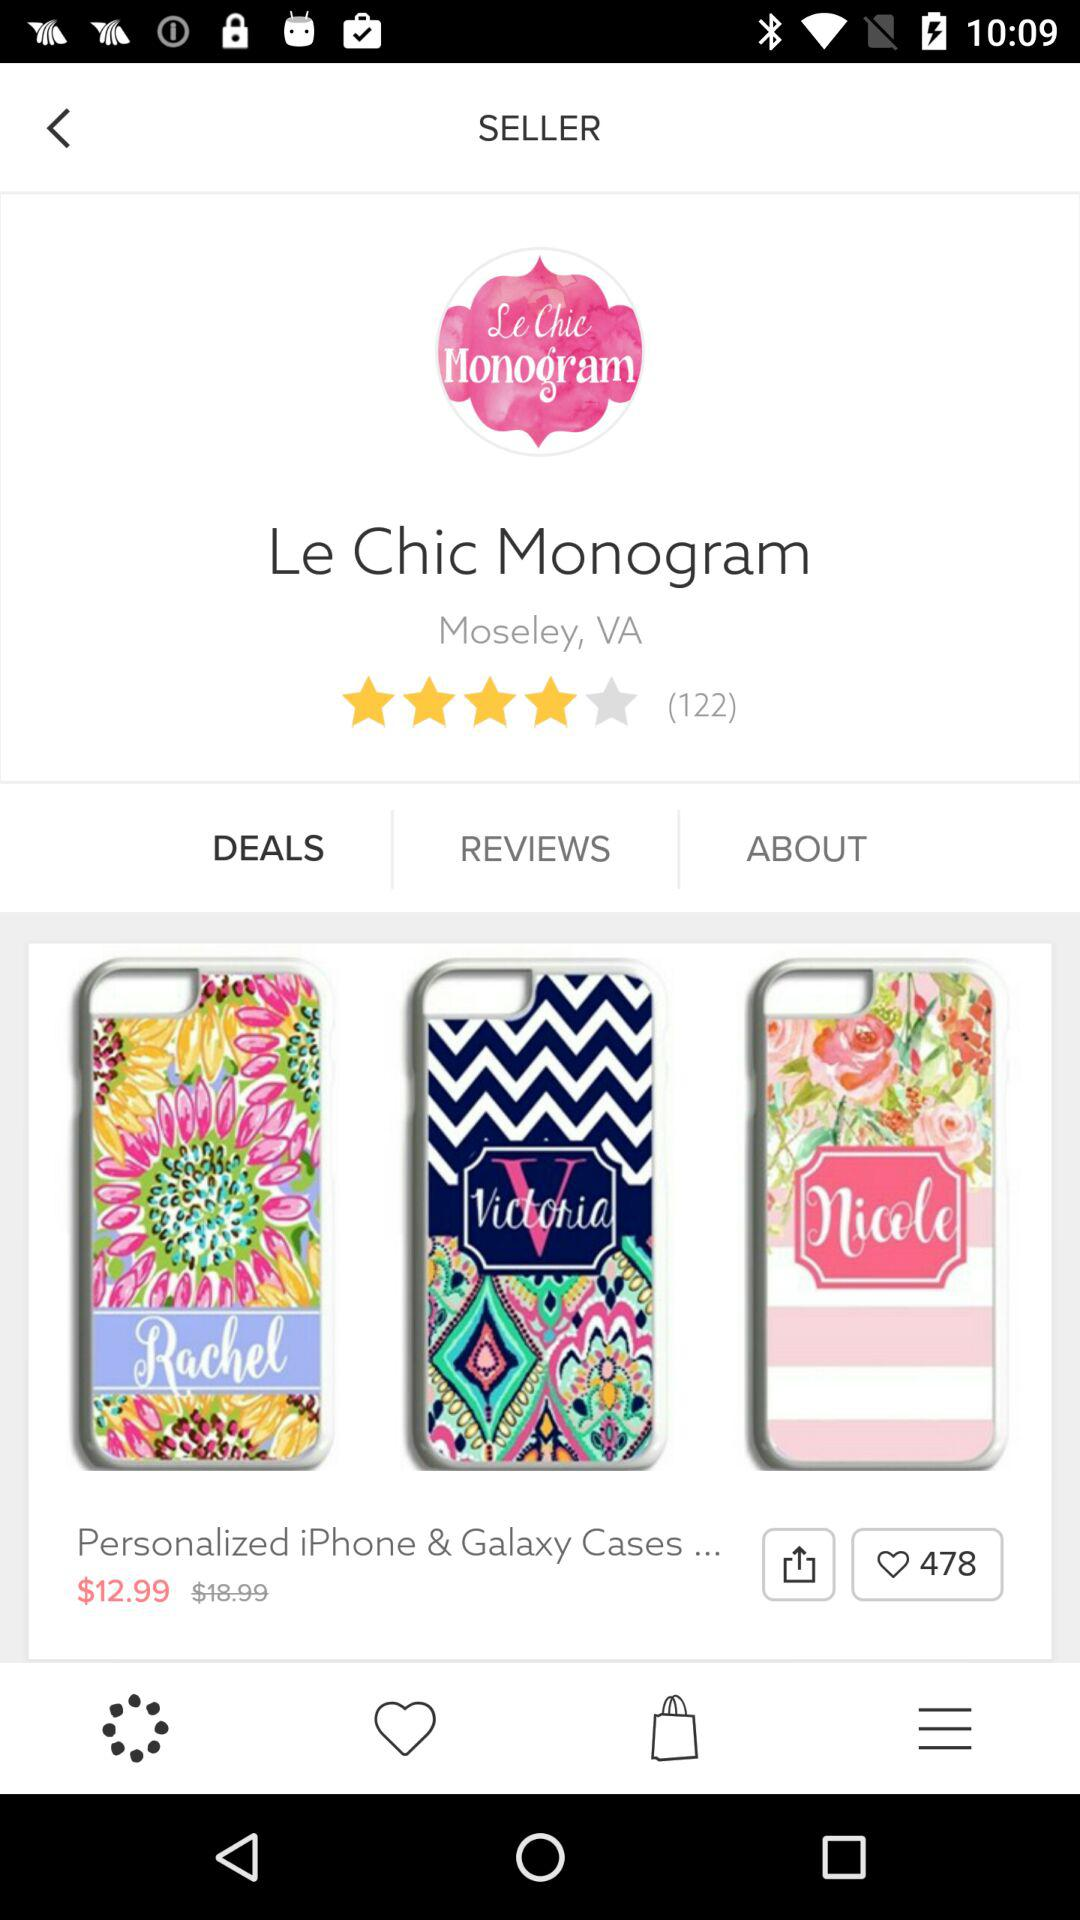How many users have rated it? It is rated by 122 users. 